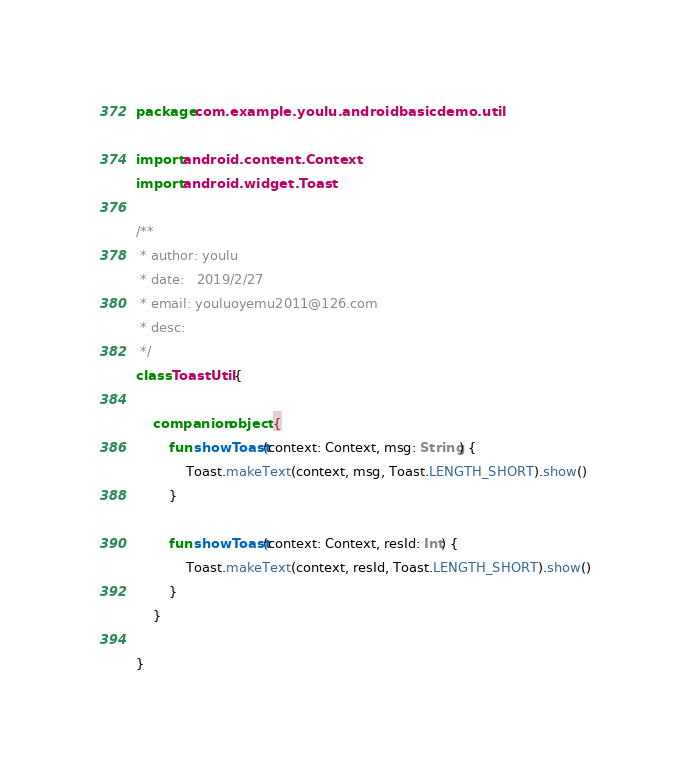<code> <loc_0><loc_0><loc_500><loc_500><_Kotlin_>package com.example.youlu.androidbasicdemo.util

import android.content.Context
import android.widget.Toast

/**
 * author: youlu
 * date:   2019/2/27
 * email: youluoyemu2011@126.com
 * desc:
 */
class ToastUtil {

    companion object {
        fun showToast(context: Context, msg: String) {
            Toast.makeText(context, msg, Toast.LENGTH_SHORT).show()
        }

        fun showToast(context: Context, resId: Int) {
            Toast.makeText(context, resId, Toast.LENGTH_SHORT).show()
        }
    }

}</code> 